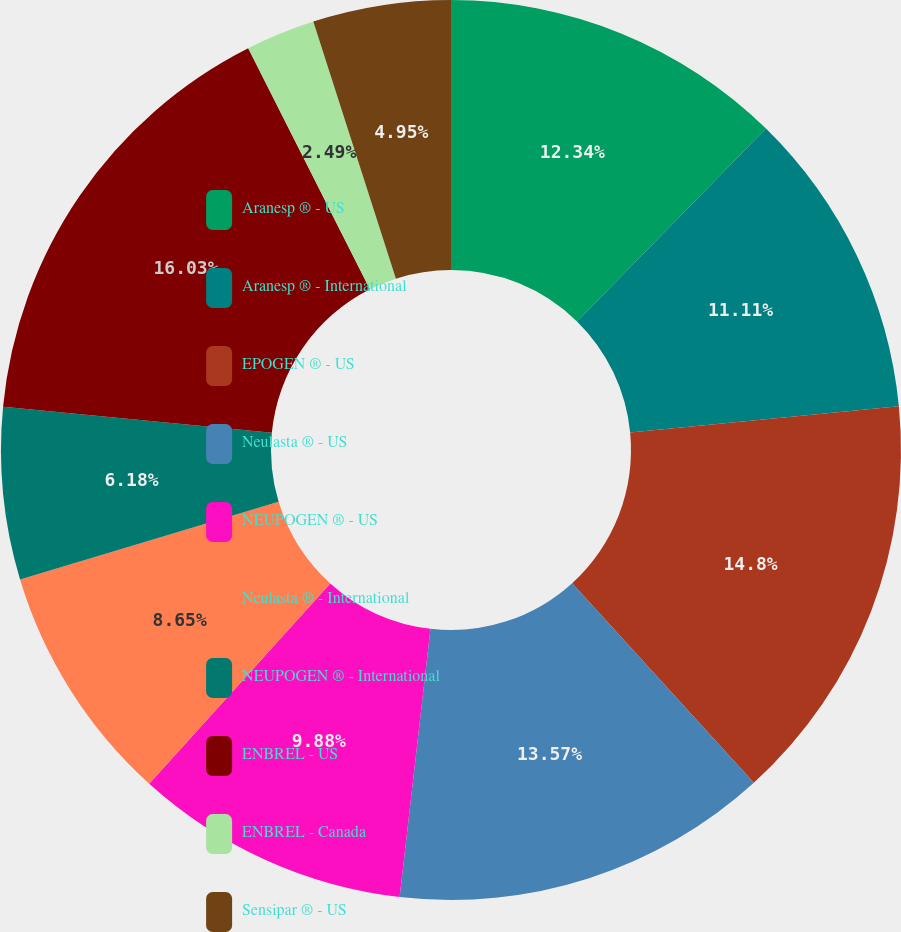Convert chart. <chart><loc_0><loc_0><loc_500><loc_500><pie_chart><fcel>Aranesp ® - US<fcel>Aranesp ® - International<fcel>EPOGEN ® - US<fcel>Neulasta ® - US<fcel>NEUPOGEN ® - US<fcel>Neulasta ® - International<fcel>NEUPOGEN ® - International<fcel>ENBREL - US<fcel>ENBREL - Canada<fcel>Sensipar ® - US<nl><fcel>12.34%<fcel>11.11%<fcel>14.8%<fcel>13.57%<fcel>9.88%<fcel>8.65%<fcel>6.18%<fcel>16.03%<fcel>2.49%<fcel>4.95%<nl></chart> 